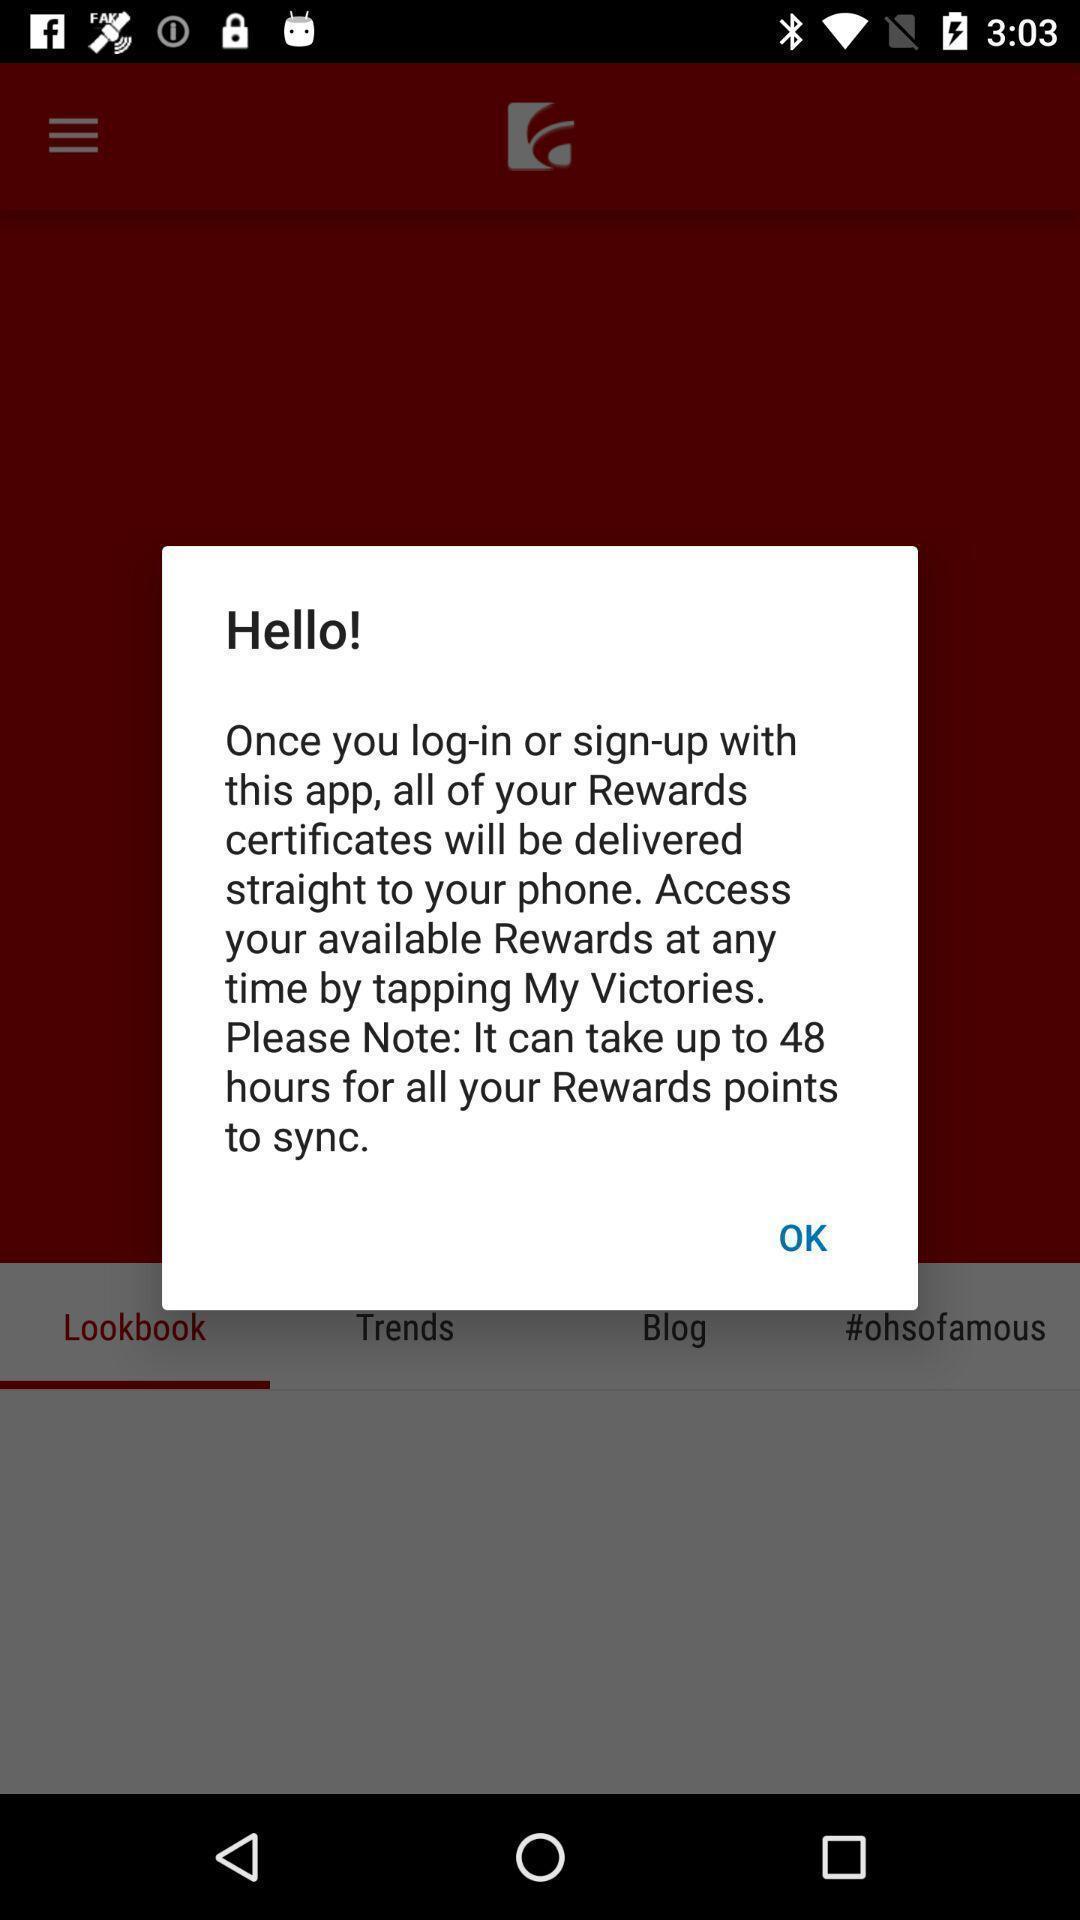Provide a description of this screenshot. Pop-up showing hello and some information. 